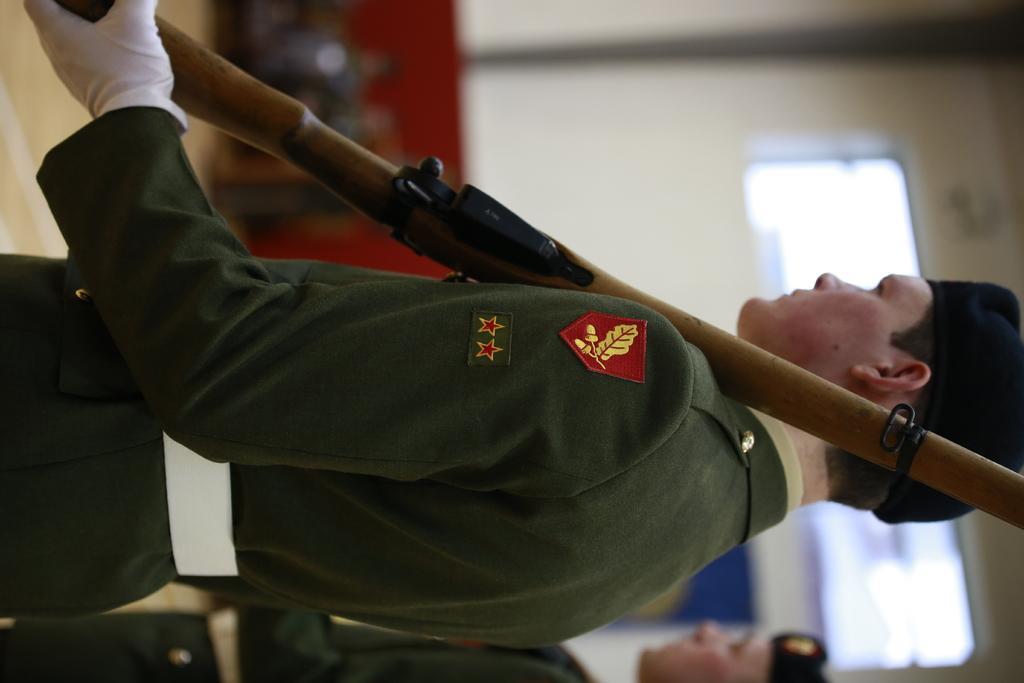Who is the main subject in the image? There is a man in the center of the image. What is the man wearing on his head? The man is wearing a cap. What is the man holding in his hand? The man is holding a gun. What can be seen in the background of the image? There are other people and a wall visible in the background of the image. What type of sock is the man wearing in the image? There is no sock visible in the image; the man is wearing a cap. 